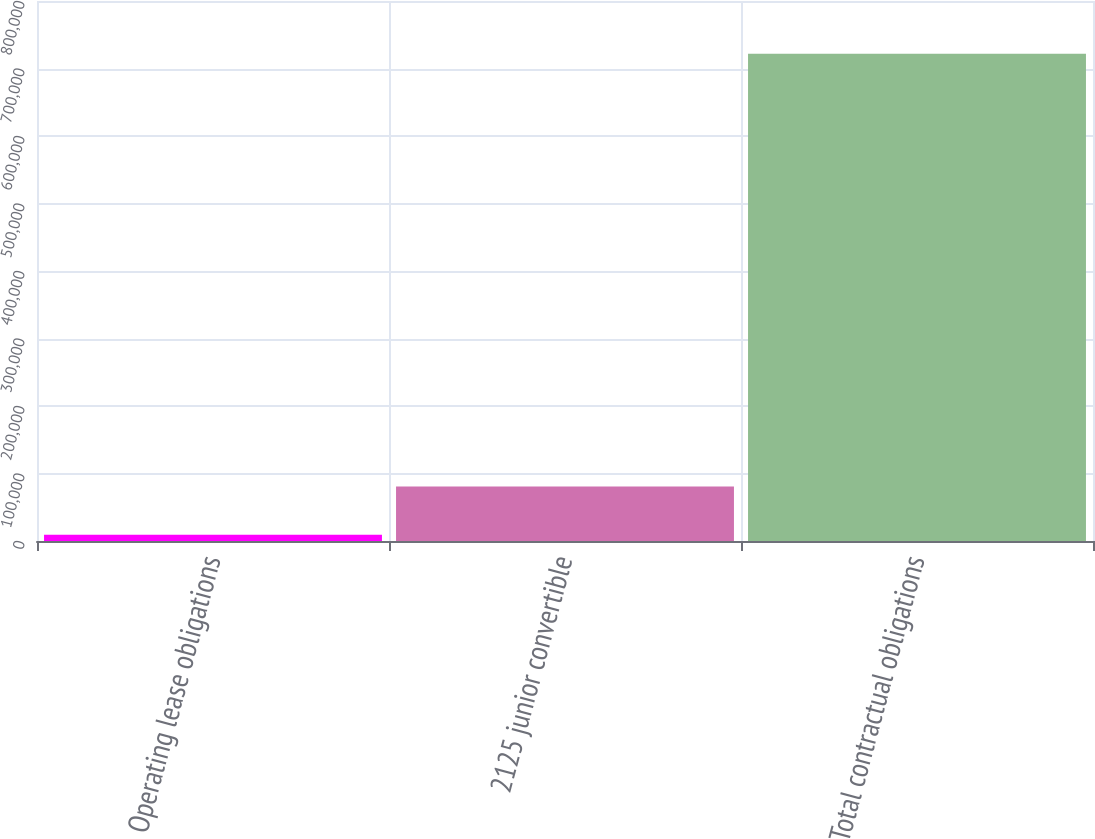<chart> <loc_0><loc_0><loc_500><loc_500><bar_chart><fcel>Operating lease obligations<fcel>2125 junior convertible<fcel>Total contractual obligations<nl><fcel>9402<fcel>80633.2<fcel>721714<nl></chart> 